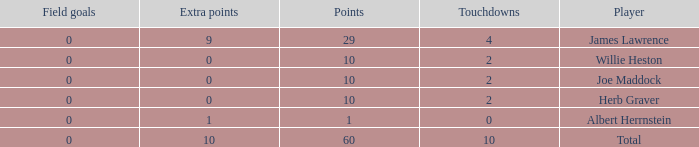What is the highest number of extra points for players with less than 2 touchdowns and less than 1 point? None. Can you give me this table as a dict? {'header': ['Field goals', 'Extra points', 'Points', 'Touchdowns', 'Player'], 'rows': [['0', '9', '29', '4', 'James Lawrence'], ['0', '0', '10', '2', 'Willie Heston'], ['0', '0', '10', '2', 'Joe Maddock'], ['0', '0', '10', '2', 'Herb Graver'], ['0', '1', '1', '0', 'Albert Herrnstein'], ['0', '10', '60', '10', 'Total']]} 